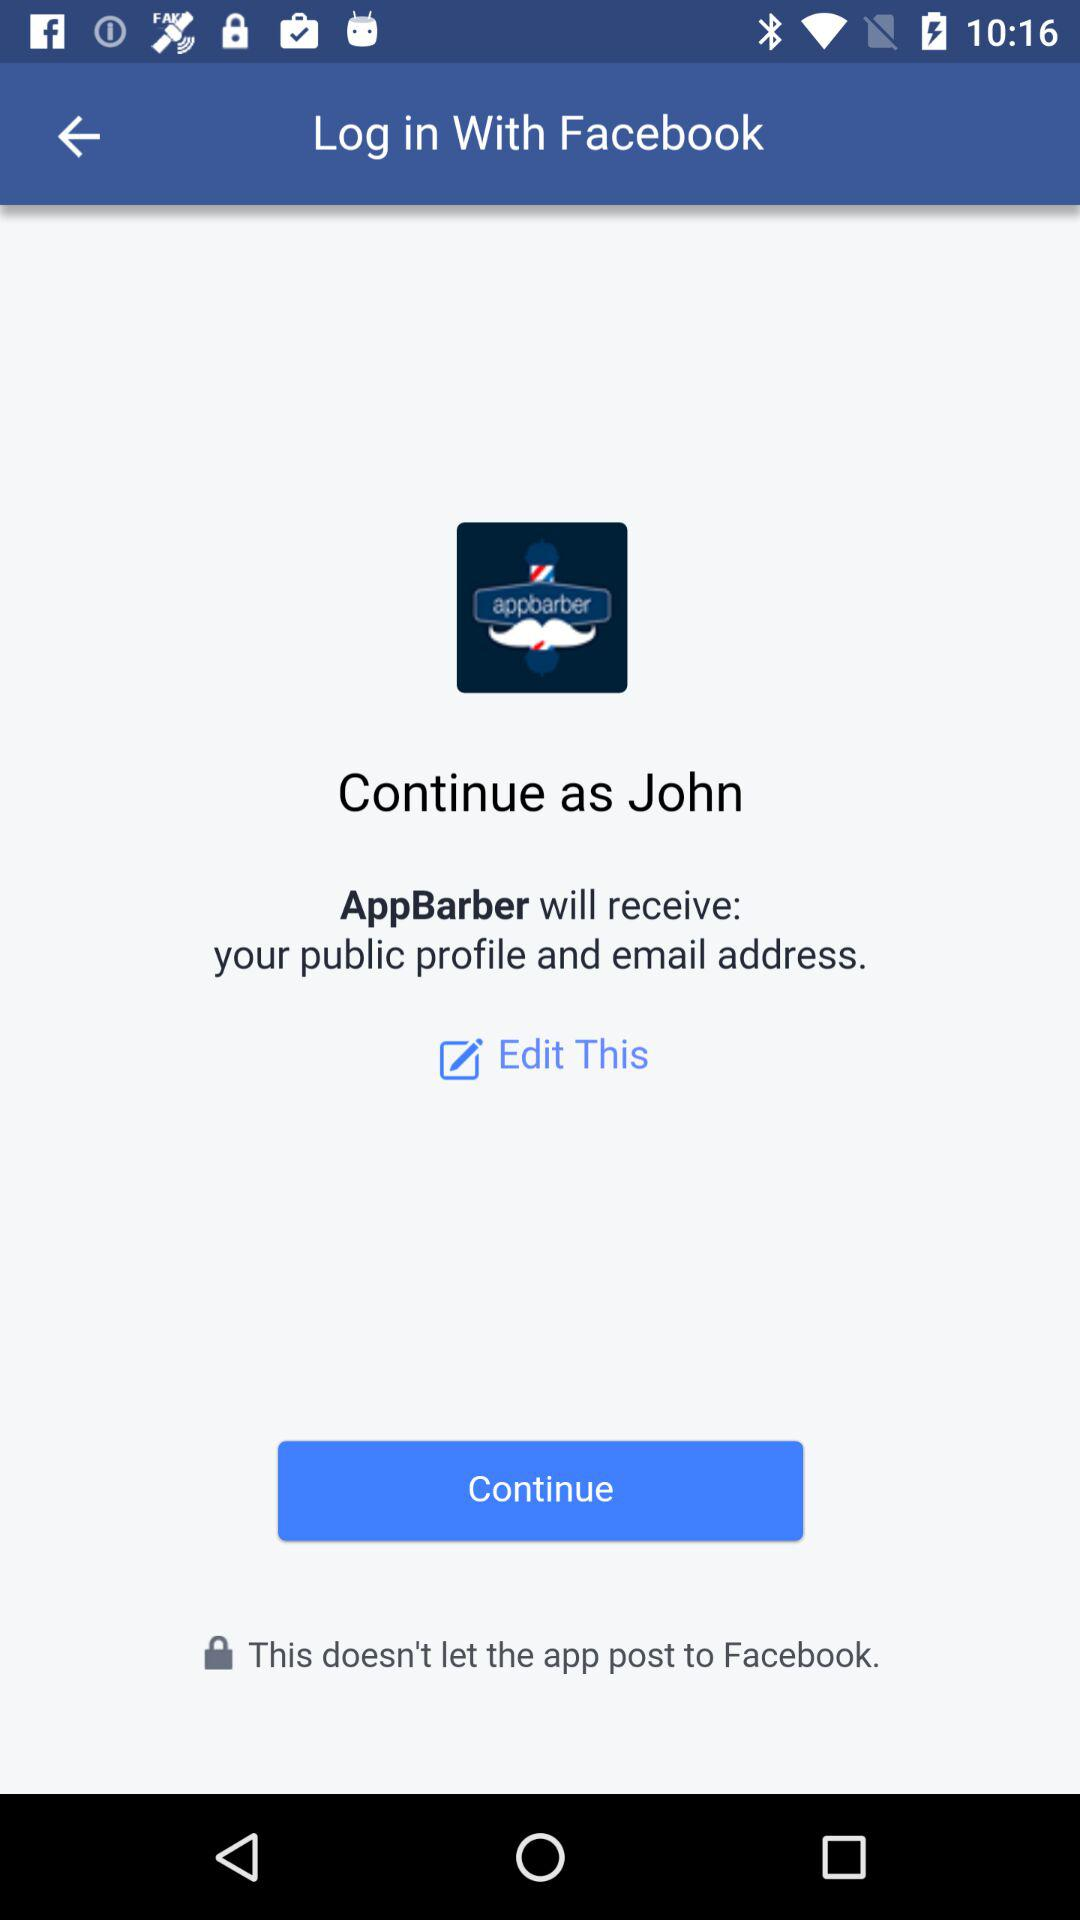What is the name of the user? The name of the user is John. 